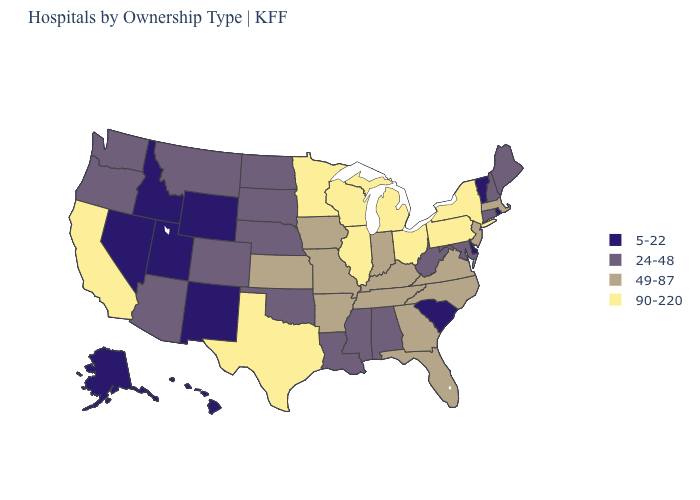What is the highest value in the West ?
Answer briefly. 90-220. Among the states that border New York , which have the lowest value?
Short answer required. Vermont. Name the states that have a value in the range 90-220?
Concise answer only. California, Illinois, Michigan, Minnesota, New York, Ohio, Pennsylvania, Texas, Wisconsin. Name the states that have a value in the range 5-22?
Short answer required. Alaska, Delaware, Hawaii, Idaho, Nevada, New Mexico, Rhode Island, South Carolina, Utah, Vermont, Wyoming. Among the states that border Idaho , which have the lowest value?
Concise answer only. Nevada, Utah, Wyoming. Name the states that have a value in the range 24-48?
Write a very short answer. Alabama, Arizona, Colorado, Connecticut, Louisiana, Maine, Maryland, Mississippi, Montana, Nebraska, New Hampshire, North Dakota, Oklahoma, Oregon, South Dakota, Washington, West Virginia. Does Virginia have the highest value in the South?
Concise answer only. No. What is the lowest value in the USA?
Answer briefly. 5-22. Which states have the lowest value in the USA?
Concise answer only. Alaska, Delaware, Hawaii, Idaho, Nevada, New Mexico, Rhode Island, South Carolina, Utah, Vermont, Wyoming. What is the value of North Carolina?
Quick response, please. 49-87. Does Connecticut have the highest value in the USA?
Short answer required. No. What is the lowest value in the South?
Concise answer only. 5-22. What is the value of Florida?
Answer briefly. 49-87. How many symbols are there in the legend?
Give a very brief answer. 4. 